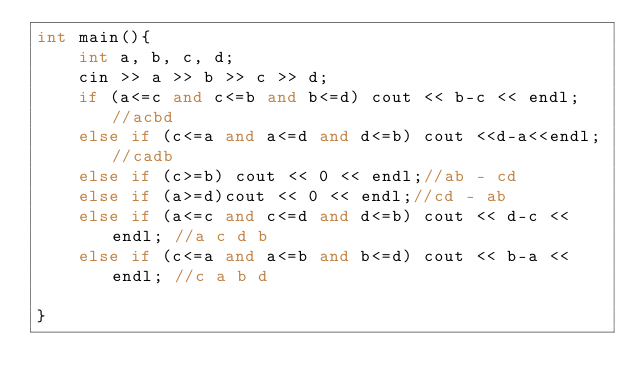Convert code to text. <code><loc_0><loc_0><loc_500><loc_500><_C++_>int main(){
	int a, b, c, d;
	cin >> a >> b >> c >> d;
	if (a<=c and c<=b and b<=d) cout << b-c << endl; //acbd
	else if (c<=a and a<=d and d<=b) cout <<d-a<<endl;//cadb
	else if (c>=b) cout << 0 << endl;//ab - cd
	else if (a>=d)cout << 0 << endl;//cd - ab
	else if (a<=c and c<=d and d<=b) cout << d-c << endl; //a c d b
	else if (c<=a and a<=b and b<=d) cout << b-a << endl; //c a b d
	
}</code> 